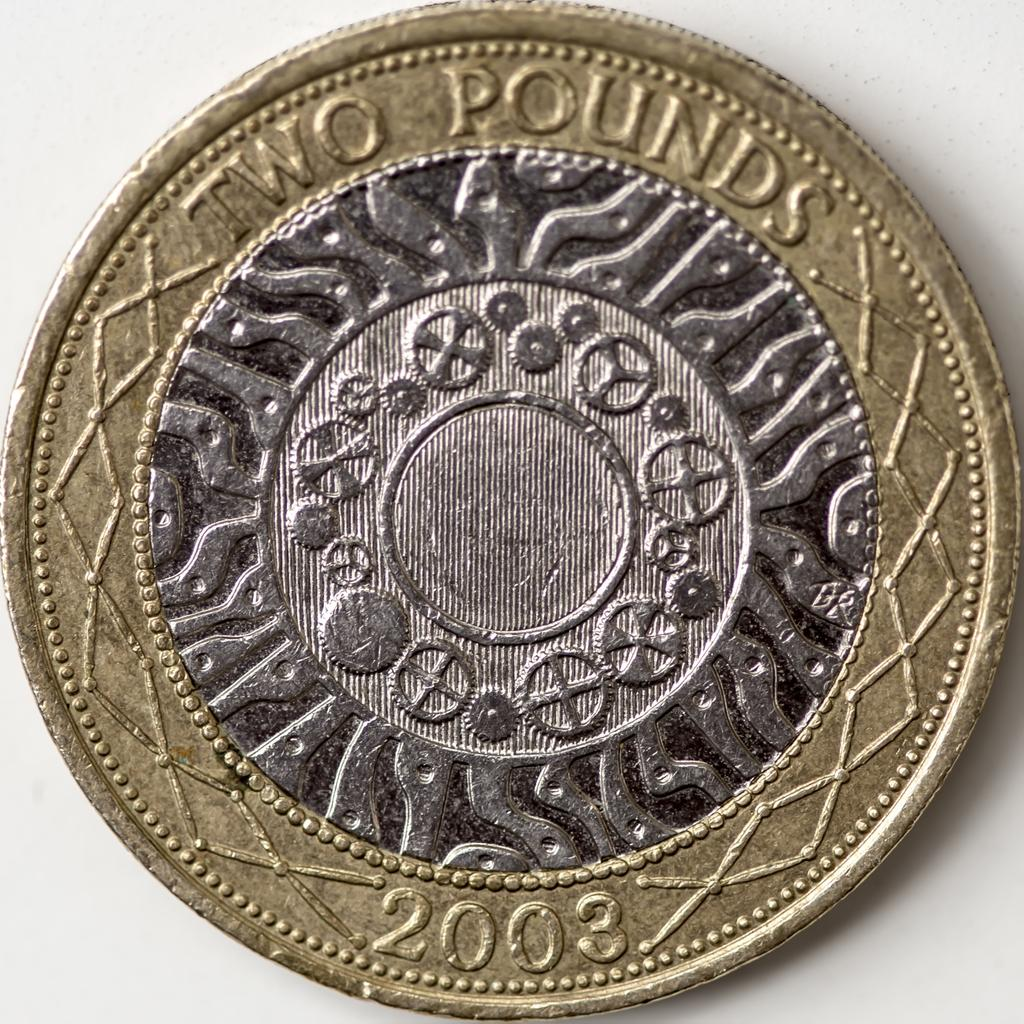Provide a one-sentence caption for the provided image. Two pound cent made in 2003 with a gold ring around the outside and silver inside. 